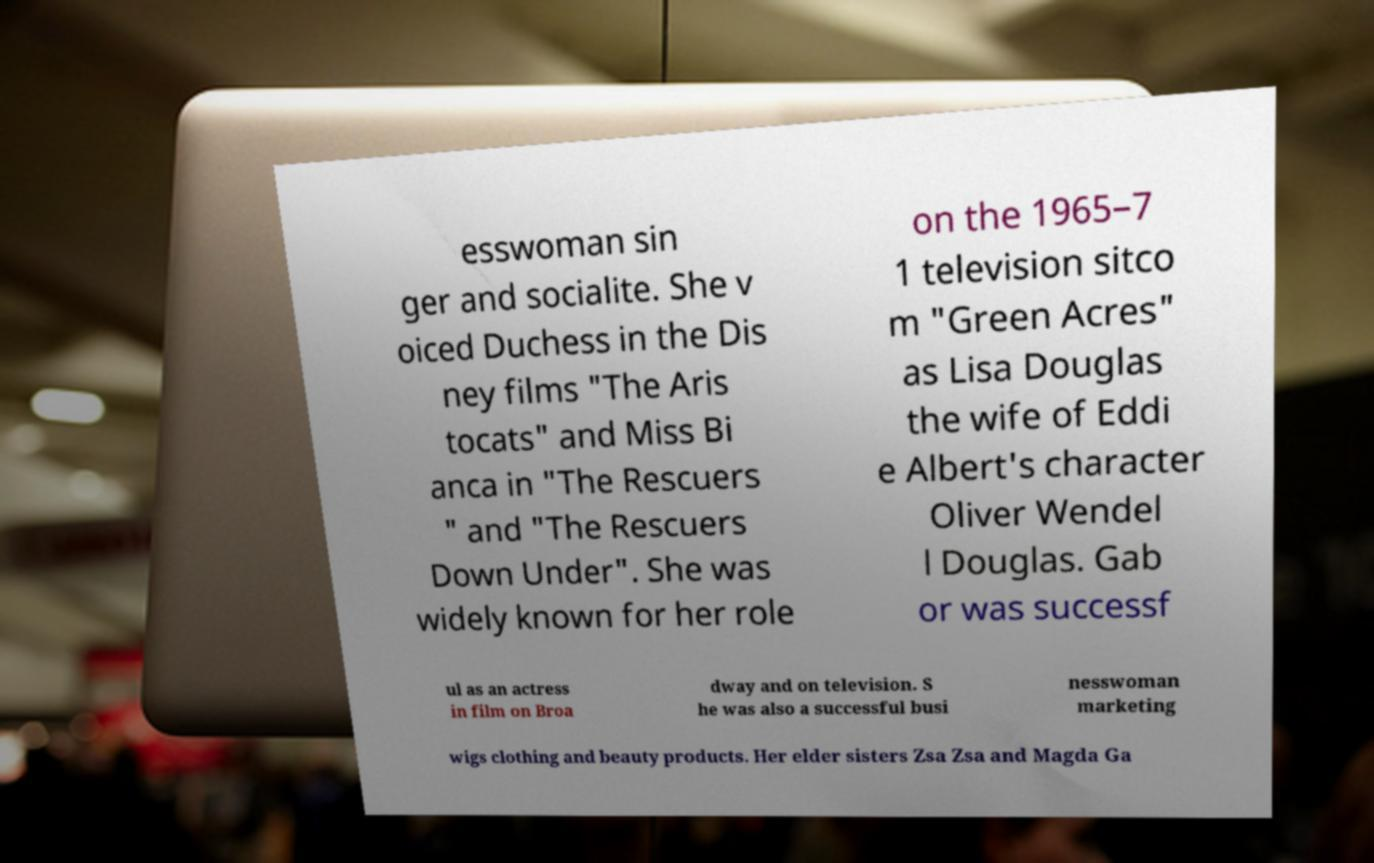Can you accurately transcribe the text from the provided image for me? esswoman sin ger and socialite. She v oiced Duchess in the Dis ney films "The Aris tocats" and Miss Bi anca in "The Rescuers " and "The Rescuers Down Under". She was widely known for her role on the 1965–7 1 television sitco m "Green Acres" as Lisa Douglas the wife of Eddi e Albert's character Oliver Wendel l Douglas. Gab or was successf ul as an actress in film on Broa dway and on television. S he was also a successful busi nesswoman marketing wigs clothing and beauty products. Her elder sisters Zsa Zsa and Magda Ga 